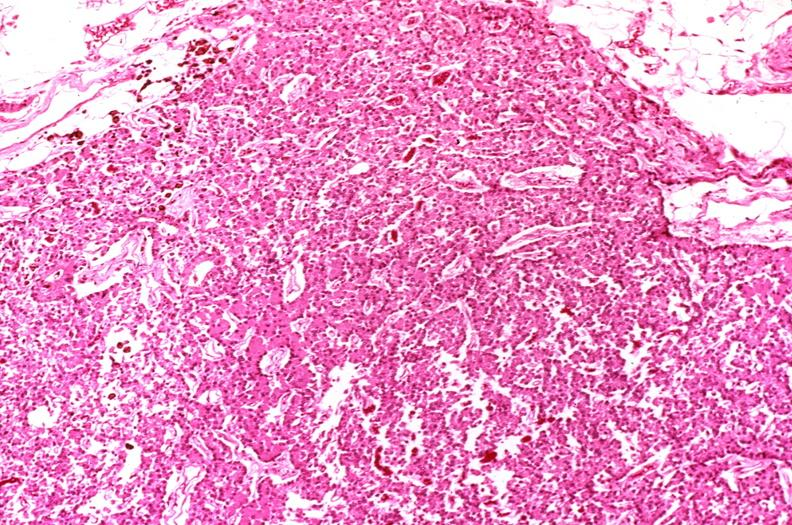does acute peritonitis show parathyroid, hyperplasia?
Answer the question using a single word or phrase. No 